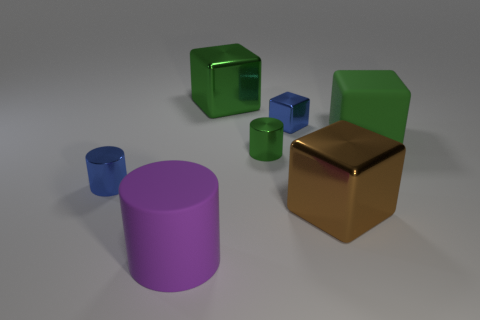Could you describe the lighting and the mood in the image? The image is lit with a soft, diffused light which creates subtle shadows around the objects. This type of lighting gives the scene a calm, peaceful mood, with no harsh shadows or bright highlights to create drama or tension. 